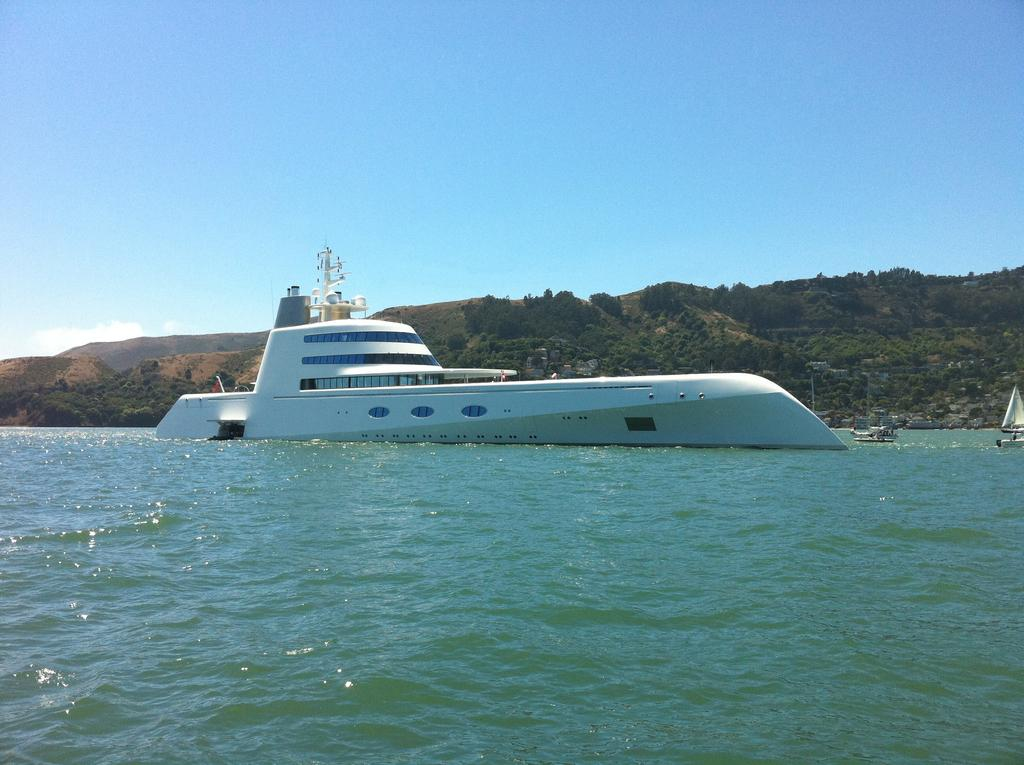What is the main subject of the image? The main subject of the image is a ship. What is the ship's location in relation to the water? The ship is floating on the water. What other geographical feature can be seen in the image? There is a hill in the middle of the image. What is visible at the top of the image? The sky is visible at the top of the image. What direction is the ship heading towards in the image? The provided facts do not indicate the direction the ship is heading in the image. --- Facts: 1. There is a person sitting on a bench in the image. 2. The person is reading a book. 3. There is a tree behind the bench. 4. The sky is visible at the top of the image. Absurd Topics: dance, car, mountain Conversation: What is the person in the image doing? The person is sitting on a bench and reading a book. What object is the person using while sitting on the bench? The person is reading a book. What type of vegetation is visible behind the bench? There is a tree behind the bench. What is visible at the top of the image? The sky is visible at the top of the image. Reasoning: Let's think step by step in order to produce the conversation. We start by identifying the main subject of the image, which is the person sitting on the bench. Then, we describe the person's activity, which is reading a book. Next, we mention the presence of a tree as another element in the image. Finally, we describe the sky visible at the top of the image. Absurd Question/Answer: What type of dance is the person performing in the image? The provided facts do not indicate that the person is dancing in the image. --- Facts: 1. There is a car in the image. 2. The car is parked on the street. 3. There are buildings in the background of the image. 4. The sky is visible at the top of the image. Absurd Topics: bird, ocean, flower Conversation: What is the main subject of the image? The main subject of the image is a car. Where is the car located in the image? The car is parked on the street. What type of structures can be seen in the background of the image? There are buildings in the background of the image. What is visible at the top of the image? The sky is visible at the top of the image. Reasoning: Let's think step by step in order to produce the conversation. We start by identifying the main subject of the image, which is the car. Then, we describe the car's location and its relationship to the street. Next, we mention the presence of buildings as another element in the image. Finally, we describe 